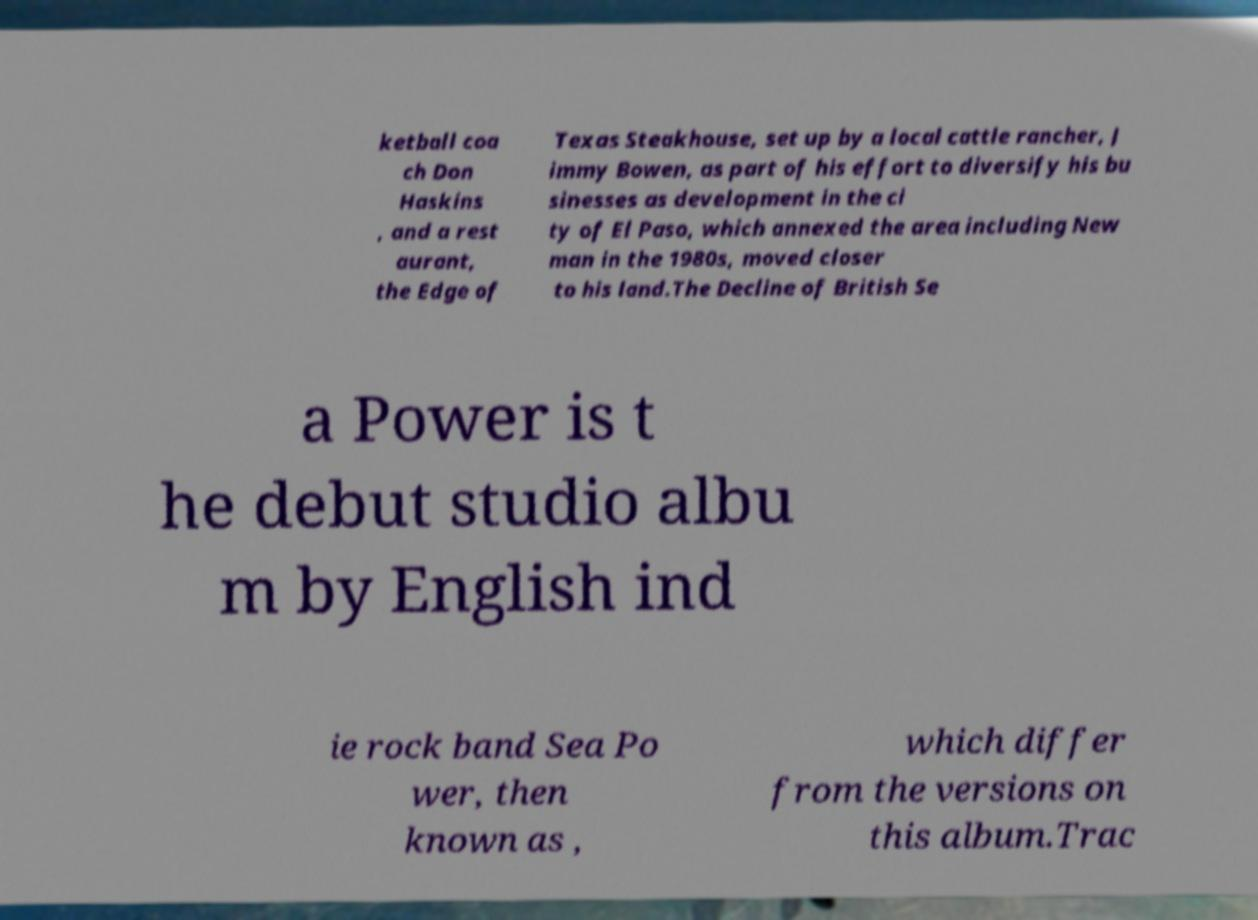Could you assist in decoding the text presented in this image and type it out clearly? ketball coa ch Don Haskins , and a rest aurant, the Edge of Texas Steakhouse, set up by a local cattle rancher, J immy Bowen, as part of his effort to diversify his bu sinesses as development in the ci ty of El Paso, which annexed the area including New man in the 1980s, moved closer to his land.The Decline of British Se a Power is t he debut studio albu m by English ind ie rock band Sea Po wer, then known as , which differ from the versions on this album.Trac 